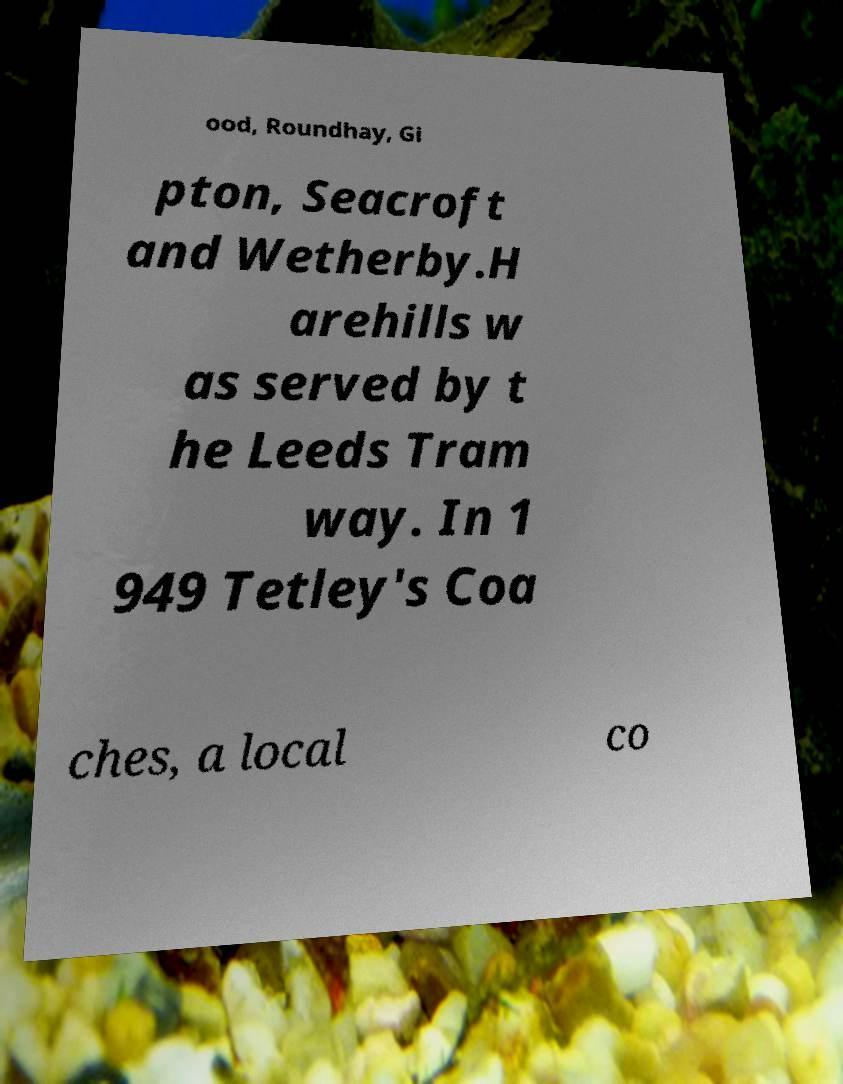Please identify and transcribe the text found in this image. ood, Roundhay, Gi pton, Seacroft and Wetherby.H arehills w as served by t he Leeds Tram way. In 1 949 Tetley's Coa ches, a local co 